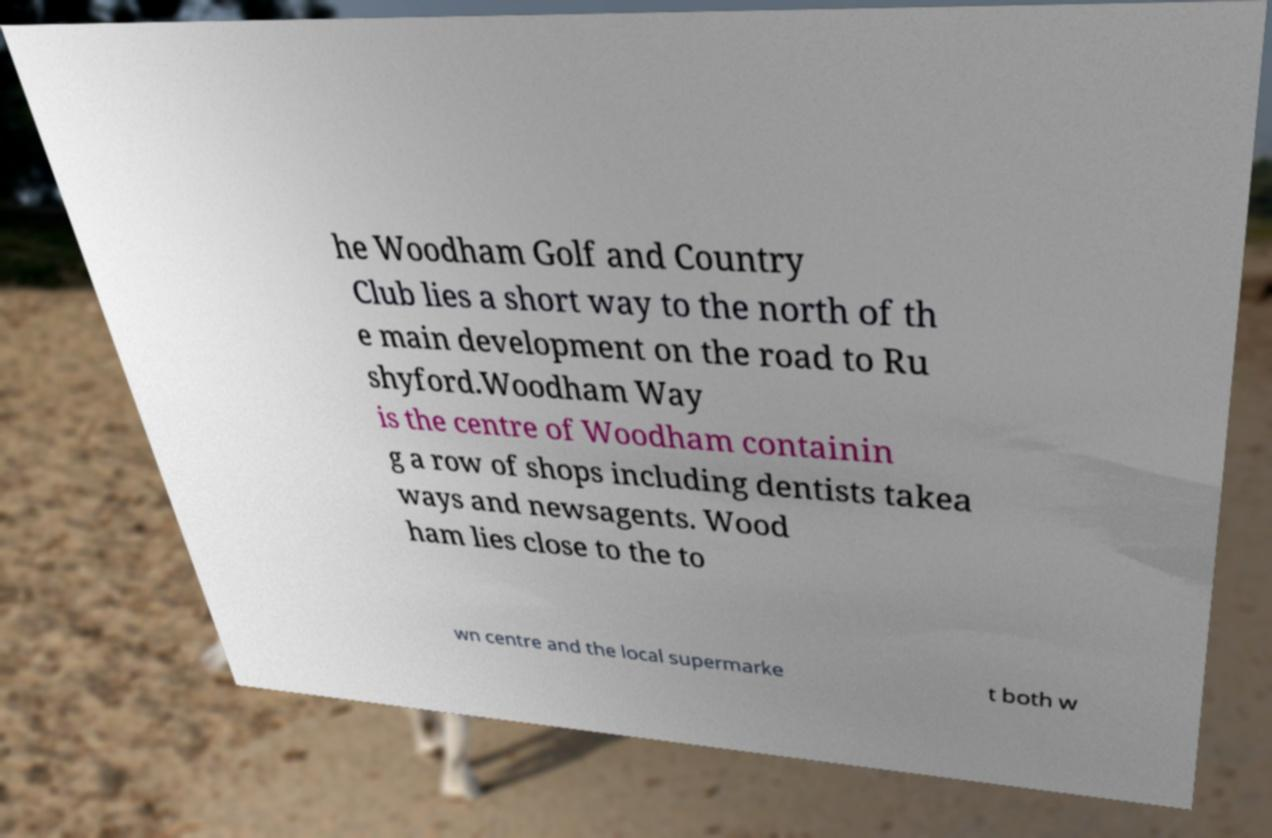Could you assist in decoding the text presented in this image and type it out clearly? he Woodham Golf and Country Club lies a short way to the north of th e main development on the road to Ru shyford.Woodham Way is the centre of Woodham containin g a row of shops including dentists takea ways and newsagents. Wood ham lies close to the to wn centre and the local supermarke t both w 